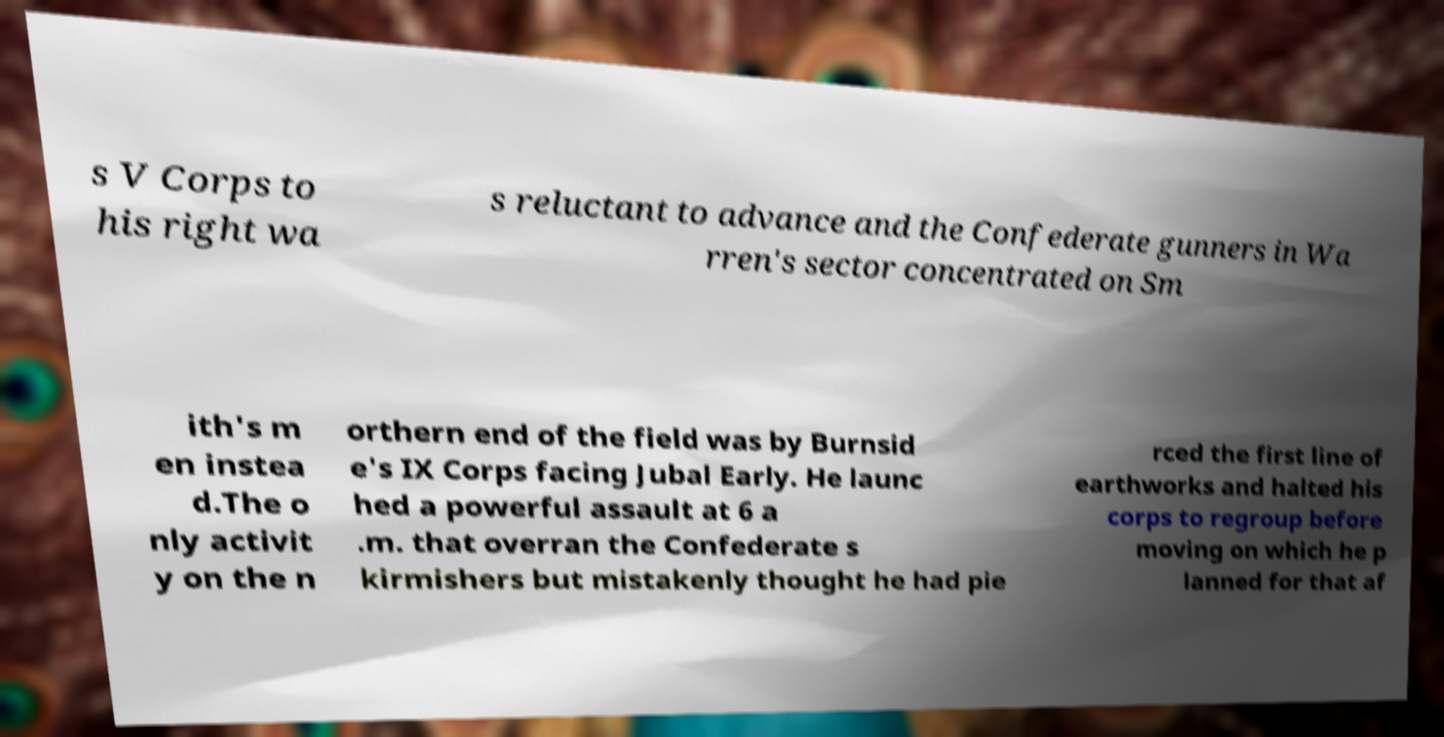I need the written content from this picture converted into text. Can you do that? s V Corps to his right wa s reluctant to advance and the Confederate gunners in Wa rren's sector concentrated on Sm ith's m en instea d.The o nly activit y on the n orthern end of the field was by Burnsid e's IX Corps facing Jubal Early. He launc hed a powerful assault at 6 a .m. that overran the Confederate s kirmishers but mistakenly thought he had pie rced the first line of earthworks and halted his corps to regroup before moving on which he p lanned for that af 